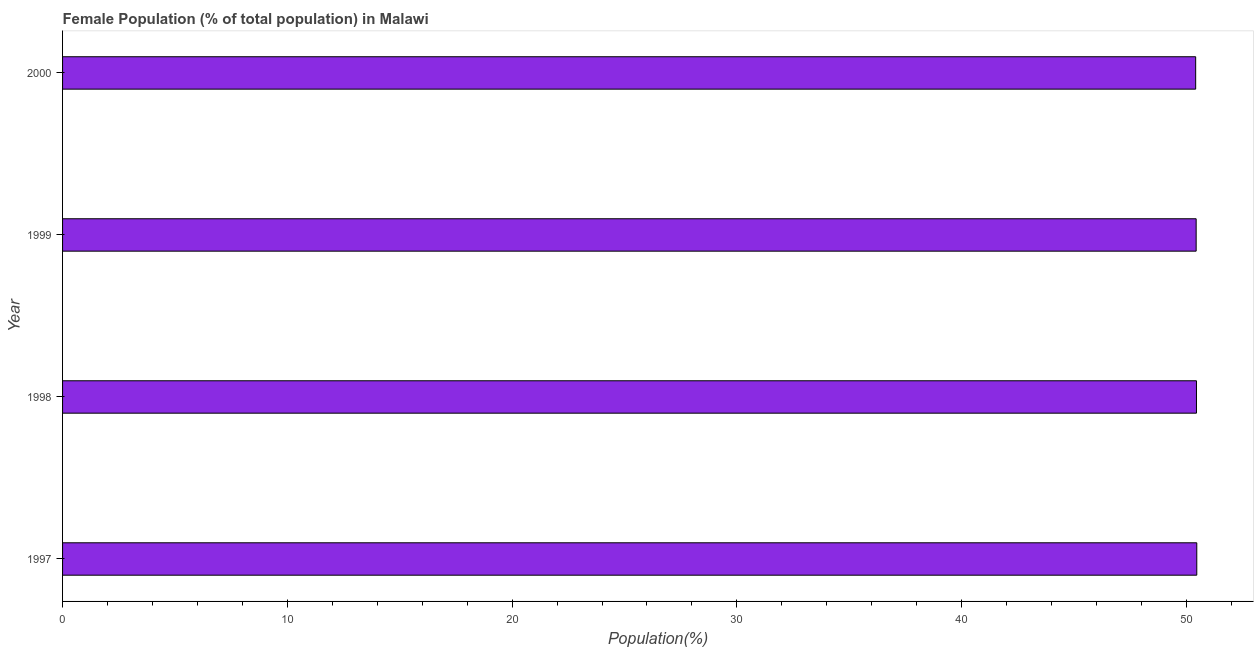What is the title of the graph?
Offer a terse response. Female Population (% of total population) in Malawi. What is the label or title of the X-axis?
Give a very brief answer. Population(%). What is the label or title of the Y-axis?
Give a very brief answer. Year. What is the female population in 2000?
Offer a very short reply. 50.41. Across all years, what is the maximum female population?
Give a very brief answer. 50.46. Across all years, what is the minimum female population?
Provide a succinct answer. 50.41. In which year was the female population minimum?
Your response must be concise. 2000. What is the sum of the female population?
Offer a very short reply. 201.75. What is the difference between the female population in 1997 and 1999?
Offer a very short reply. 0.03. What is the average female population per year?
Offer a very short reply. 50.44. What is the median female population?
Your response must be concise. 50.44. Do a majority of the years between 1998 and 2000 (inclusive) have female population greater than 38 %?
Provide a succinct answer. Yes. What is the ratio of the female population in 1998 to that in 1999?
Ensure brevity in your answer.  1. Is the female population in 1997 less than that in 2000?
Keep it short and to the point. No. What is the difference between the highest and the second highest female population?
Provide a short and direct response. 0.01. Are all the bars in the graph horizontal?
Keep it short and to the point. Yes. How many years are there in the graph?
Provide a short and direct response. 4. Are the values on the major ticks of X-axis written in scientific E-notation?
Offer a very short reply. No. What is the Population(%) in 1997?
Your response must be concise. 50.46. What is the Population(%) of 1998?
Your response must be concise. 50.45. What is the Population(%) of 1999?
Keep it short and to the point. 50.43. What is the Population(%) in 2000?
Provide a short and direct response. 50.41. What is the difference between the Population(%) in 1997 and 1998?
Provide a succinct answer. 0.01. What is the difference between the Population(%) in 1997 and 1999?
Your response must be concise. 0.03. What is the difference between the Population(%) in 1997 and 2000?
Offer a terse response. 0.05. What is the difference between the Population(%) in 1998 and 1999?
Ensure brevity in your answer.  0.01. What is the difference between the Population(%) in 1998 and 2000?
Your answer should be compact. 0.04. What is the difference between the Population(%) in 1999 and 2000?
Offer a terse response. 0.02. What is the ratio of the Population(%) in 1997 to that in 1999?
Offer a terse response. 1. What is the ratio of the Population(%) in 1998 to that in 1999?
Offer a very short reply. 1. What is the ratio of the Population(%) in 1998 to that in 2000?
Provide a short and direct response. 1. What is the ratio of the Population(%) in 1999 to that in 2000?
Offer a terse response. 1. 